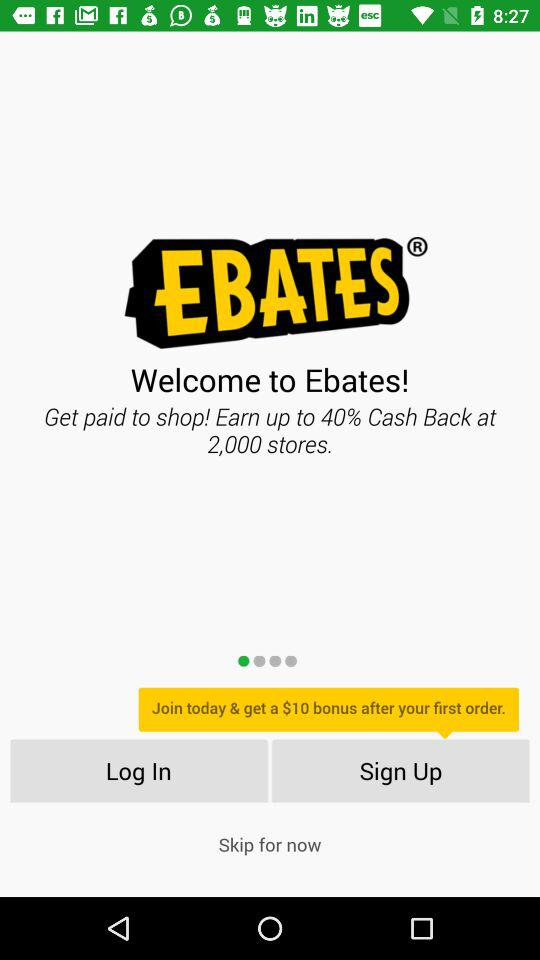What is the cashback percentage? The cashback is up to 40%. 